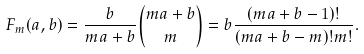Convert formula to latex. <formula><loc_0><loc_0><loc_500><loc_500>F _ { m } ( a , b ) & = \frac { b } { m a + b } \binom { m a + b } { m } = b \frac { ( m a + b - 1 ) ! } { ( m a + b - m ) ! m ! } .</formula> 